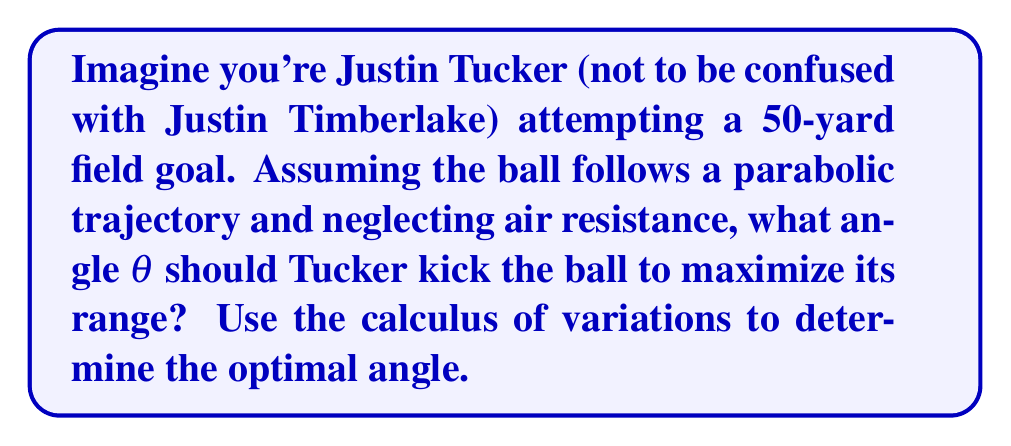Show me your answer to this math problem. Let's approach this step-by-step using the calculus of variations:

1) The trajectory of the ball can be described by the equation:

   $$y = x \tan θ - \frac{gx^2}{2v_0^2 \cos^2 θ}$$

   where $g$ is the acceleration due to gravity, $v_0$ is the initial velocity, and $x$ is the horizontal distance.

2) The range $R$ is the value of $x$ when $y = 0$:

   $$0 = R \tan θ - \frac{gR^2}{2v_0^2 \cos^2 θ}$$

3) Solving for $R$:

   $$R = \frac{2v_0^2}{g} \sin θ \cos θ = \frac{v_0^2}{g} \sin 2θ$$

4) To maximize $R$, we need to find the value of θ that maximizes $\sin 2θ$.

5) Take the derivative of $\sin 2θ$ with respect to θ:

   $$\frac{d}{dθ}(\sin 2θ) = 2 \cos 2θ$$

6) Set this equal to zero to find the maximum:

   $$2 \cos 2θ = 0$$
   $$\cos 2θ = 0$$

7) Solve for θ:

   $$2θ = \frac{\pi}{2}$$
   $$θ = \frac{\pi}{4} = 45°$$

8) The second derivative is negative at this point, confirming it's a maximum.

Therefore, the optimal angle for Tucker's kick is 45° to maximize the range.
Answer: 45° 